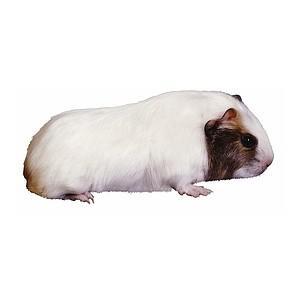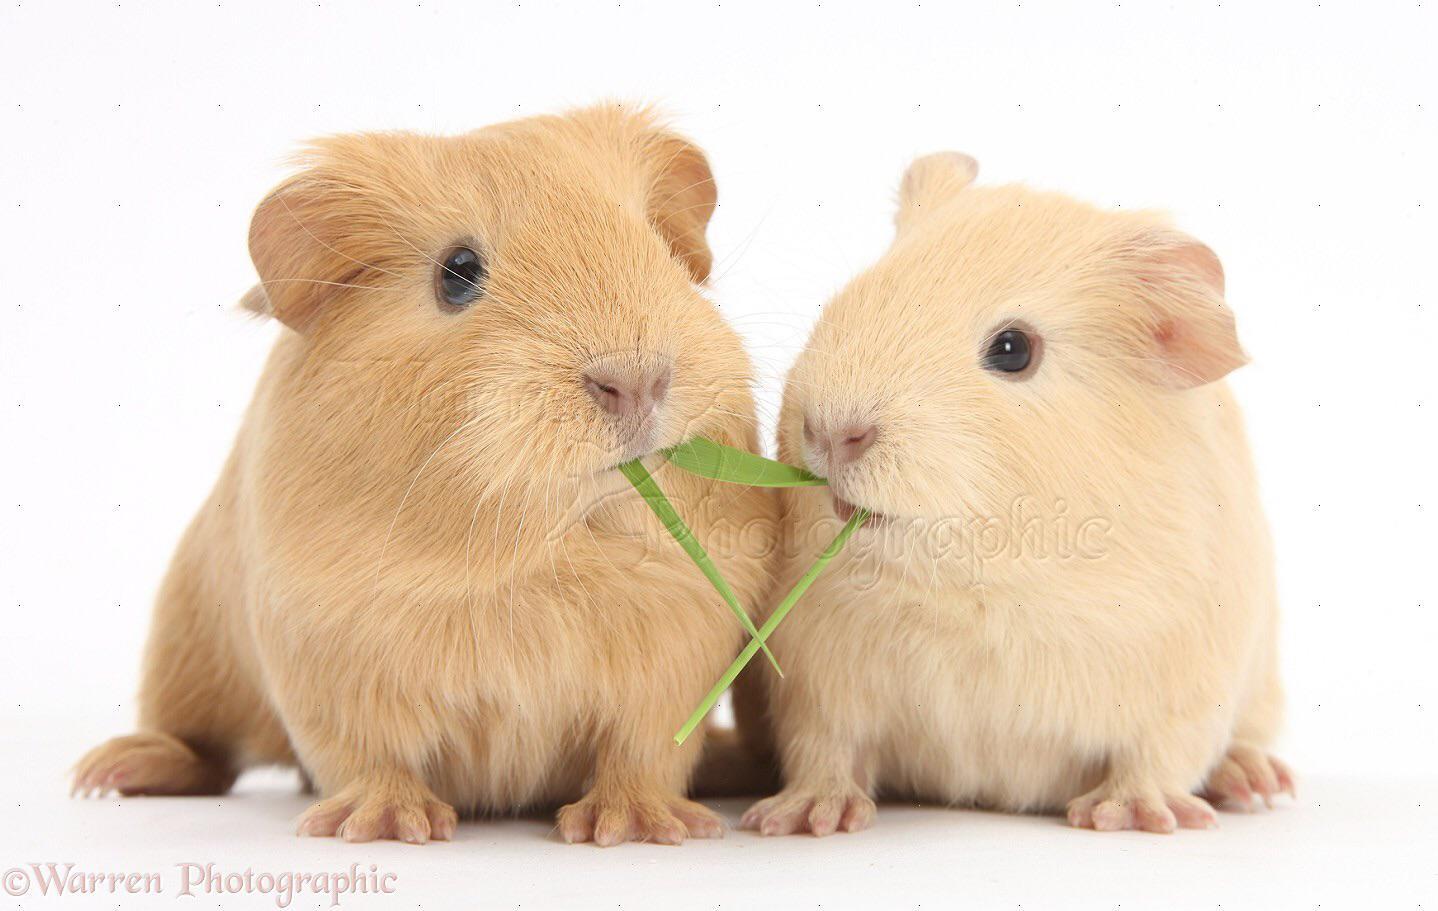The first image is the image on the left, the second image is the image on the right. Analyze the images presented: Is the assertion "There are two hamsters in total." valid? Answer yes or no. No. 